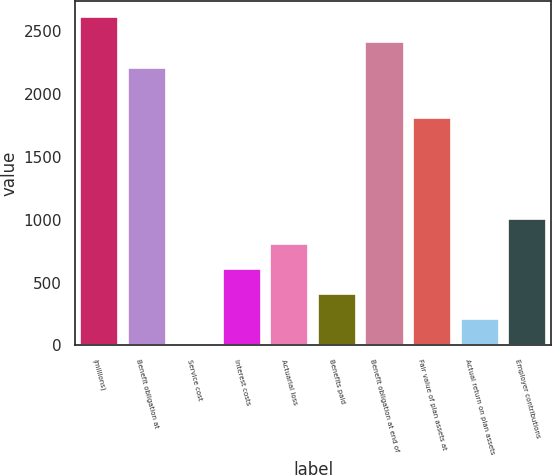<chart> <loc_0><loc_0><loc_500><loc_500><bar_chart><fcel>(millions)<fcel>Benefit obligation at<fcel>Service cost<fcel>Interest costs<fcel>Actuarial loss<fcel>Benefits paid<fcel>Benefit obligation at end of<fcel>Fair value of plan assets at<fcel>Actual return on plan assets<fcel>Employer contributions<nl><fcel>2612.44<fcel>2211.48<fcel>6.2<fcel>607.64<fcel>808.12<fcel>407.16<fcel>2411.96<fcel>1810.52<fcel>206.68<fcel>1008.6<nl></chart> 